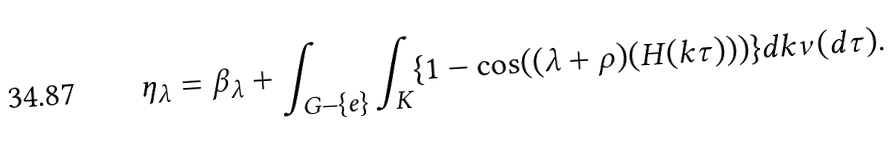<formula> <loc_0><loc_0><loc_500><loc_500>\eta _ { \lambda } = \beta _ { \lambda } + \int _ { G - \{ e \} } \int _ { K } \{ 1 - \cos ( ( \lambda + \rho ) ( H ( k \tau ) ) ) \} d k \nu ( d \tau ) .</formula> 